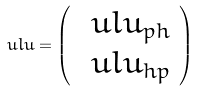<formula> <loc_0><loc_0><loc_500><loc_500>\ u l { u } = \left ( \begin{array} { c } \ u l { u } _ { p h } \\ \ u l { u } _ { h p } \end{array} \right )</formula> 